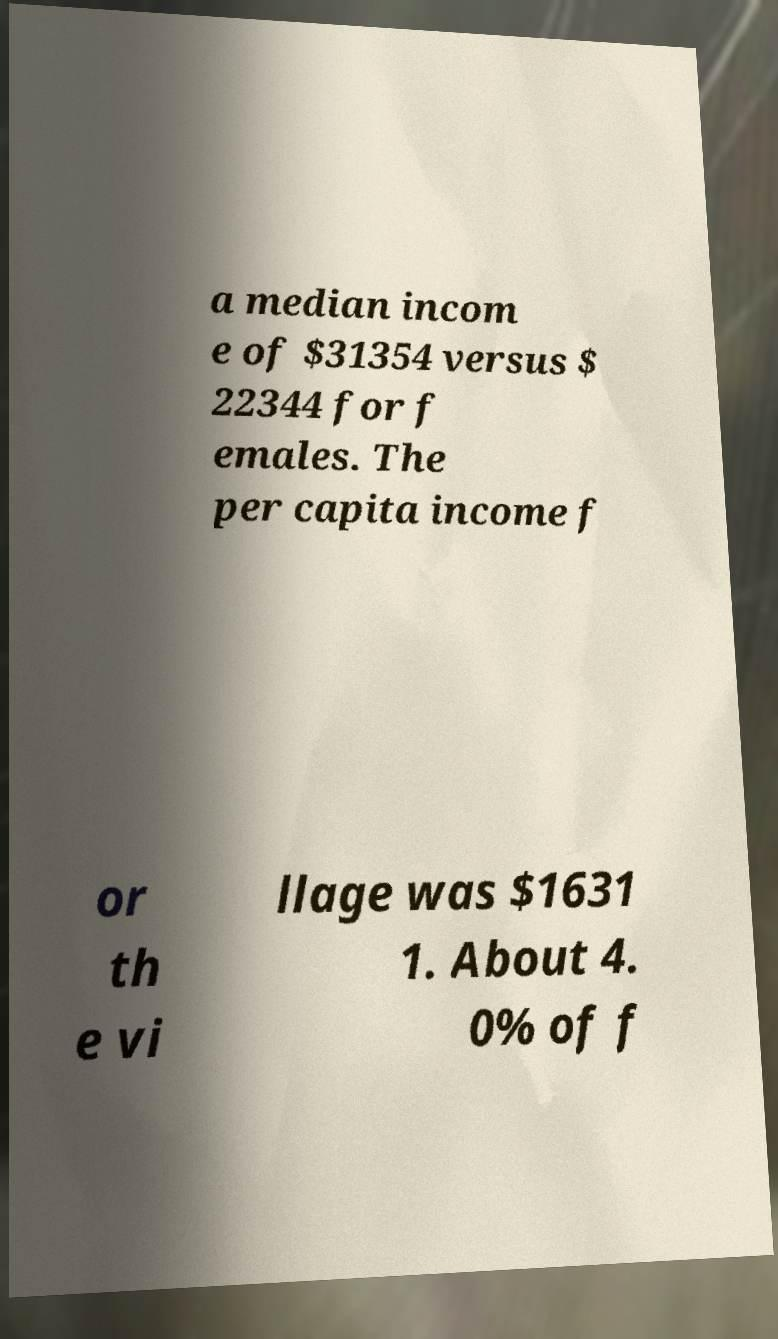For documentation purposes, I need the text within this image transcribed. Could you provide that? a median incom e of $31354 versus $ 22344 for f emales. The per capita income f or th e vi llage was $1631 1. About 4. 0% of f 